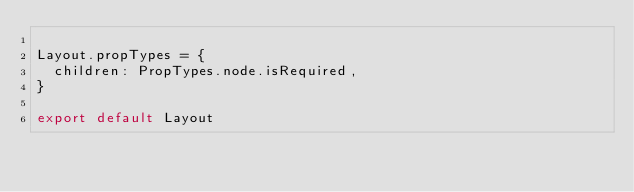<code> <loc_0><loc_0><loc_500><loc_500><_JavaScript_>
Layout.propTypes = {
  children: PropTypes.node.isRequired,
}

export default Layout
</code> 